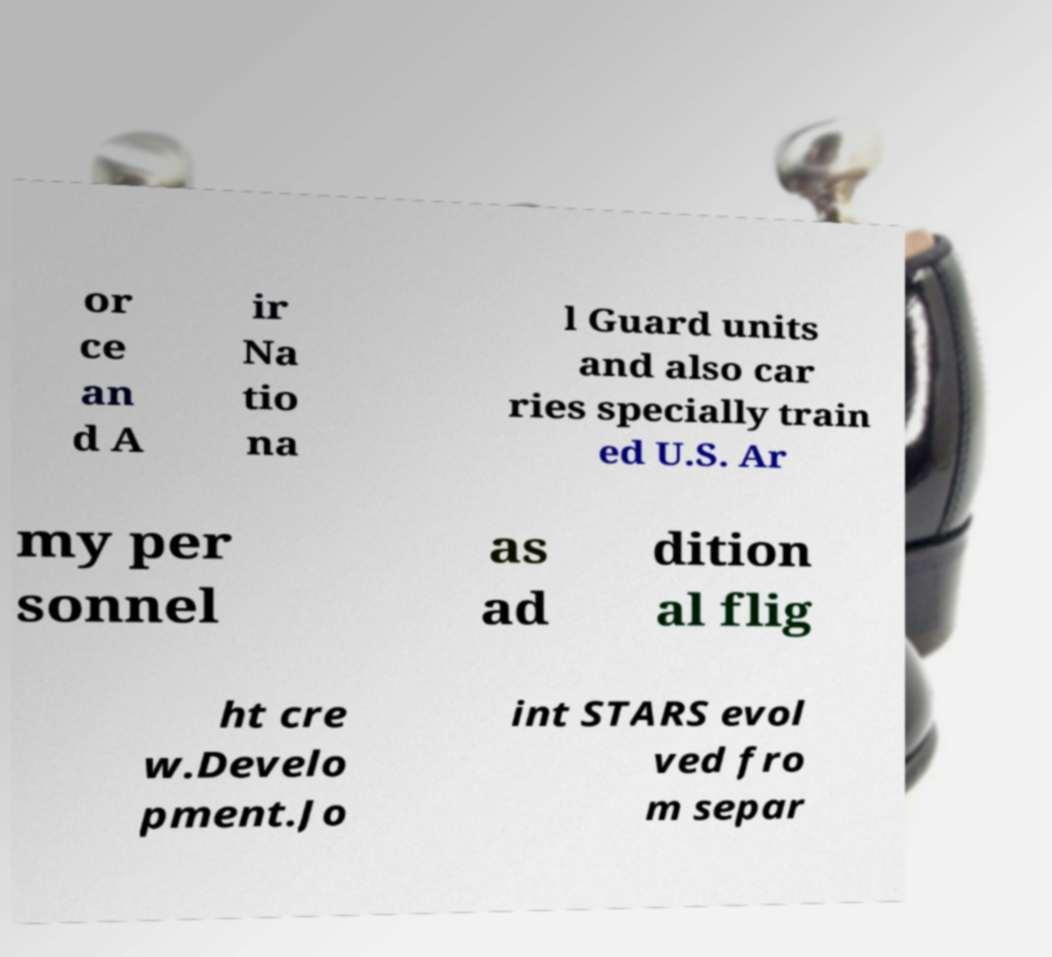Can you accurately transcribe the text from the provided image for me? or ce an d A ir Na tio na l Guard units and also car ries specially train ed U.S. Ar my per sonnel as ad dition al flig ht cre w.Develo pment.Jo int STARS evol ved fro m separ 